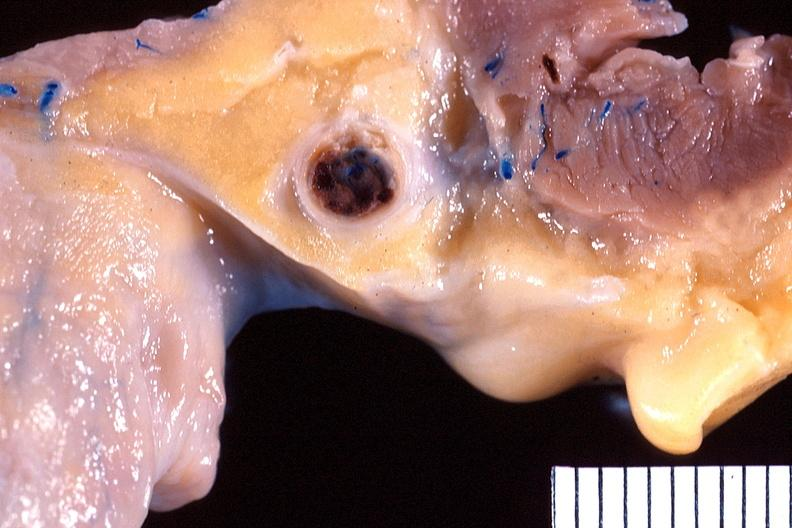what is present?
Answer the question using a single word or phrase. Cardiovascular 